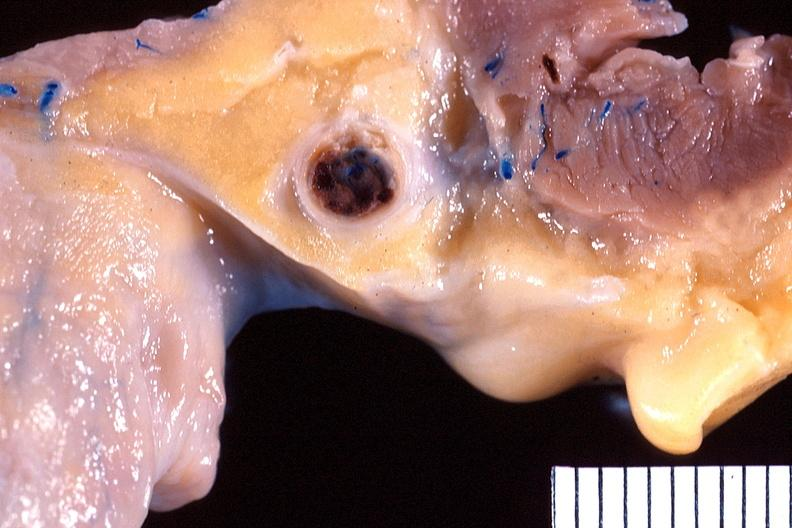what is present?
Answer the question using a single word or phrase. Cardiovascular 